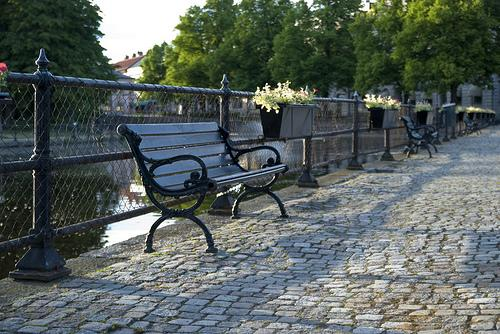What is the sidewalk made of? brick 